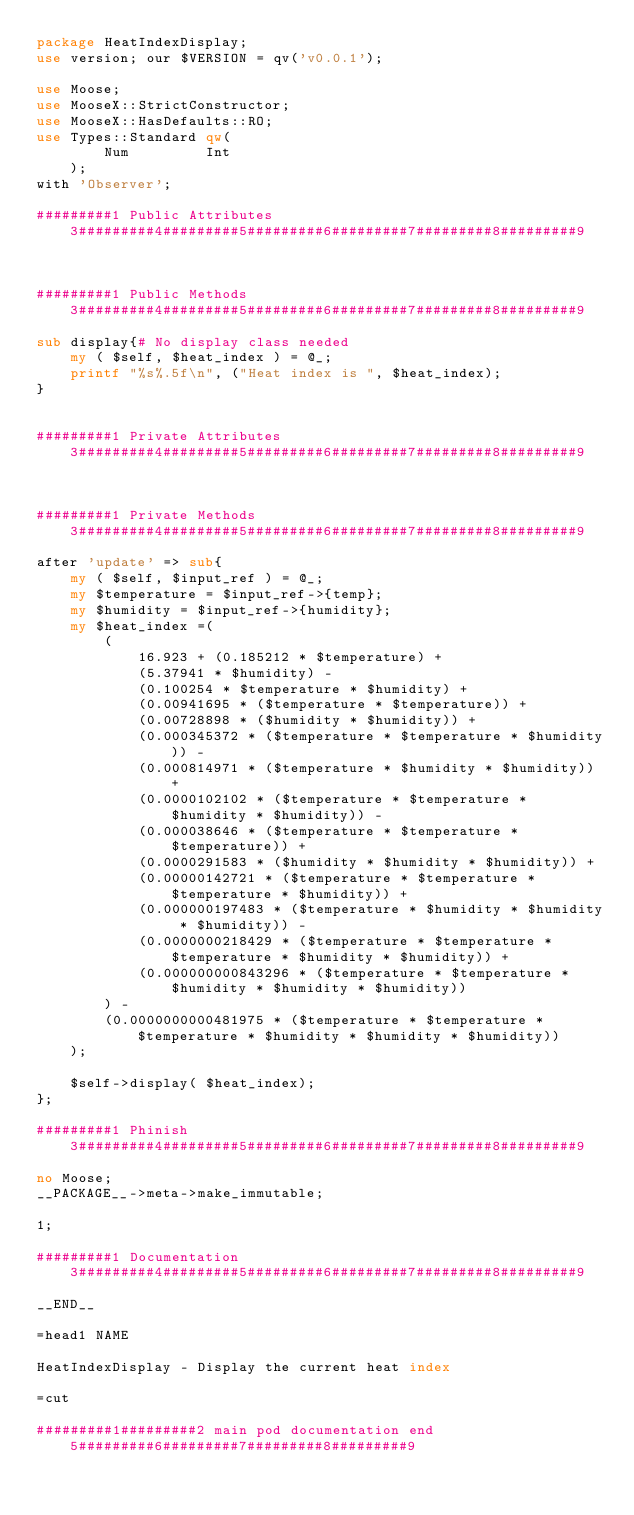Convert code to text. <code><loc_0><loc_0><loc_500><loc_500><_Perl_>package HeatIndexDisplay;
use version; our $VERSION = qv('v0.0.1');

use Moose;
use MooseX::StrictConstructor;
use MooseX::HasDefaults::RO;
use Types::Standard qw(
		Num			Int
    );
with 'Observer';

#########1 Public Attributes  3#########4#########5#########6#########7#########8#########9



#########1 Public Methods     3#########4#########5#########6#########7#########8#########9

sub display{# No display class needed
	my ( $self, $heat_index ) = @_;
	printf "%s%.5f\n", ("Heat index is ", $heat_index);
}
	

#########1 Private Attributes 3#########4#########5#########6#########7#########8#########9



#########1 Private Methods    3#########4#########5#########6#########7#########8#########9

after 'update' => sub{
	my ( $self, $input_ref ) = @_;
	my $temperature = $input_ref->{temp};
	my $humidity = $input_ref->{humidity};
	my $heat_index =(
		(
			16.923 + (0.185212 * $temperature) +
			(5.37941 * $humidity) - 
			(0.100254 * $temperature * $humidity) +
			(0.00941695 * ($temperature * $temperature)) + 
			(0.00728898 * ($humidity * $humidity)) +
			(0.000345372 * ($temperature * $temperature * $humidity)) -
			(0.000814971 * ($temperature * $humidity * $humidity)) +
			(0.0000102102 * ($temperature * $temperature * $humidity * $humidity)) - 
			(0.000038646 * ($temperature * $temperature * $temperature)) +
			(0.0000291583 * ($humidity * $humidity * $humidity)) +
			(0.00000142721 * ($temperature * $temperature * $temperature * $humidity)) + 
			(0.000000197483 * ($temperature * $humidity * $humidity * $humidity)) -
			(0.0000000218429 * ($temperature * $temperature * $temperature * $humidity * $humidity)) +
			(0.000000000843296 * ($temperature * $temperature * $humidity * $humidity * $humidity))
		) -
		(0.0000000000481975 * ($temperature * $temperature * $temperature * $humidity * $humidity * $humidity))
	);

	$self->display( $heat_index);
};

#########1 Phinish            3#########4#########5#########6#########7#########8#########9

no Moose;
__PACKAGE__->meta->make_immutable;
	
1;

#########1 Documentation      3#########4#########5#########6#########7#########8#########9

__END__

=head1 NAME

HeatIndexDisplay - Display the current heat index

=cut

#########1#########2 main pod documentation end  5#########6#########7#########8#########9
</code> 